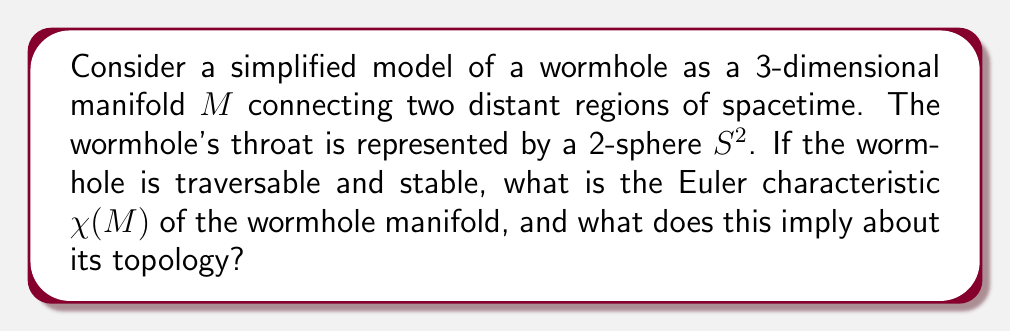What is the answer to this math problem? To analyze the topology of the wormhole using manifold theory, we'll follow these steps:

1) First, we need to understand the structure of the wormhole manifold. In this simplified model, we can think of the wormhole as two 3-dimensional regions connected by a "bridge" or "tunnel" with a spherical cross-section (the throat).

2) Topologically, this structure is equivalent to a 3-sphere $S^3$ with two 3-balls $B^3$ removed, and their boundaries identified. Let's call this manifold $M$.

3) The Euler characteristic is a topological invariant that can help us understand the structure of the manifold. For a 3-dimensional manifold $M$, the Euler characteristic is given by:

   $$\chi(M) = \chi(\partial M)$$

   where $\partial M$ is the boundary of $M$.

4) In our case, the boundary of $M$ consists of two disjoint 2-spheres (the "mouths" of the wormhole). So:

   $$\partial M = S^2 \sqcup S^2$$

5) The Euler characteristic of a 2-sphere is 2. For disjoint unions, we can add the Euler characteristics. Therefore:

   $$\chi(\partial M) = \chi(S^2) + \chi(S^2) = 2 + 2 = 4$$

6) Thus, $\chi(M) = 4$.

7) This result tells us something important about the topology of $M$. A key theorem in topology states that for a connected, orientable 3-manifold $M$:

   $$\chi(M) = \frac{1}{2}\chi(\partial M)$$

   Our result violates this theorem, which implies that $M$ is not a connected 3-manifold.

8) In fact, our wormhole manifold $M$ is homotopy equivalent to two 3-spheres connected by a line segment. This is because the throat of the wormhole (represented by $S^2$) can be continuously deformed to a point, leaving us with two separate 3-dimensional regions connected by a line.

This topology allows for the wormhole to be traversable, as there is a path connecting the two regions, and stable, as the connection between the regions is maintained.
Answer: The Euler characteristic of the wormhole manifold is $\chi(M) = 4$. This implies that the wormhole manifold is not a connected 3-manifold, but rather is homotopy equivalent to two 3-spheres connected by a line segment, allowing for a traversable and potentially stable wormhole structure. 